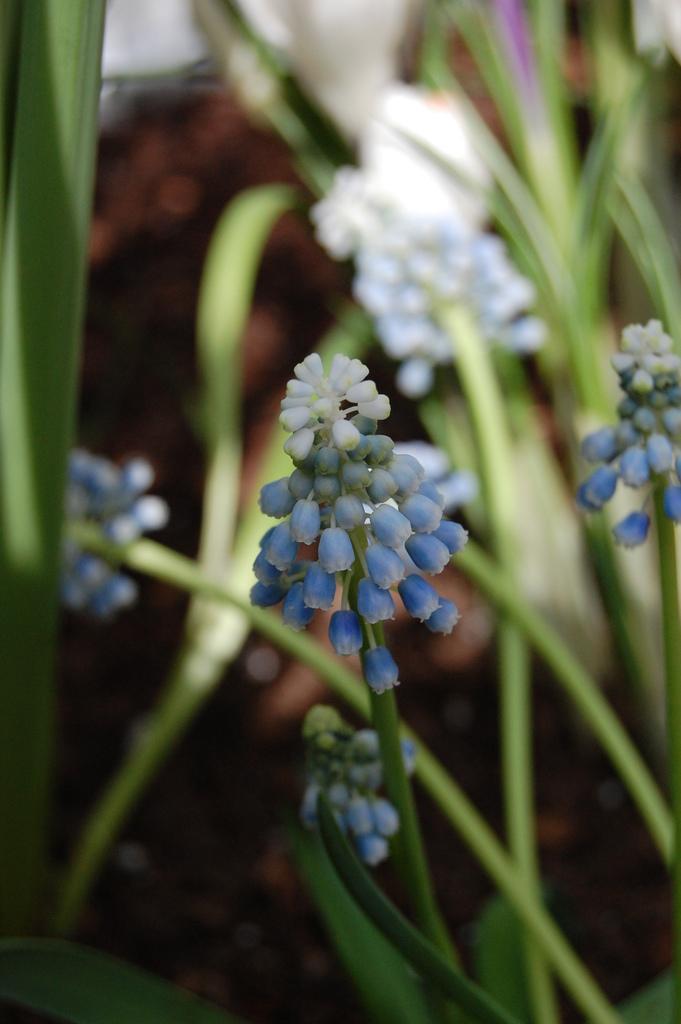In one or two sentences, can you explain what this image depicts? In this image there are plants and we can see flowers on it. 